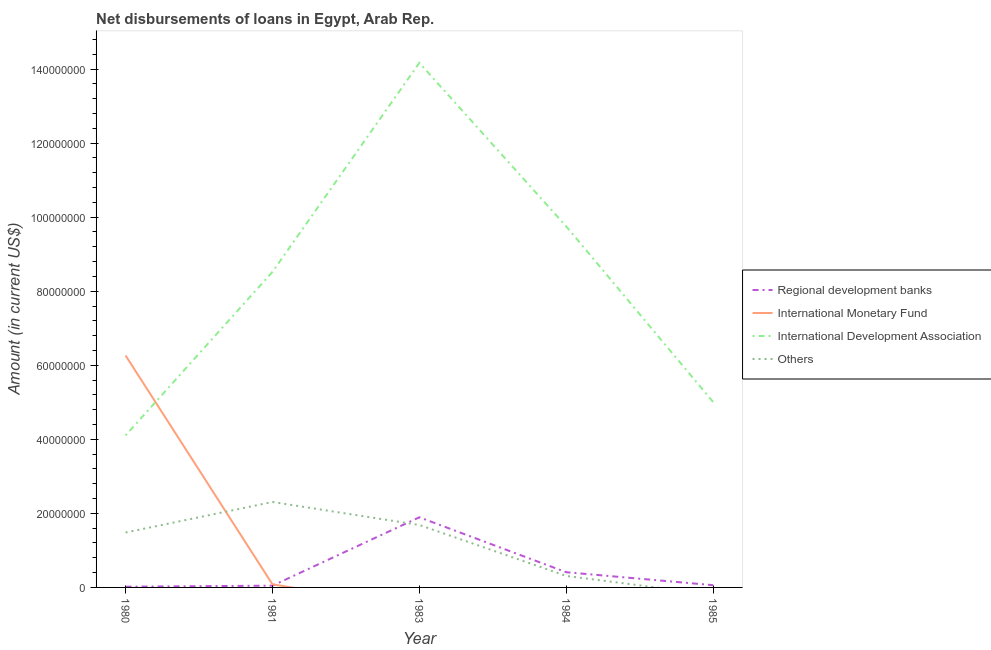How many different coloured lines are there?
Provide a succinct answer. 4. What is the amount of loan disimbursed by regional development banks in 1985?
Provide a short and direct response. 6.06e+05. Across all years, what is the maximum amount of loan disimbursed by international monetary fund?
Offer a very short reply. 6.26e+07. Across all years, what is the minimum amount of loan disimbursed by international monetary fund?
Give a very brief answer. 0. In which year was the amount of loan disimbursed by international monetary fund maximum?
Keep it short and to the point. 1980. What is the total amount of loan disimbursed by regional development banks in the graph?
Provide a short and direct response. 2.43e+07. What is the difference between the amount of loan disimbursed by other organisations in 1980 and that in 1981?
Offer a very short reply. -8.25e+06. What is the difference between the amount of loan disimbursed by regional development banks in 1984 and the amount of loan disimbursed by international monetary fund in 1983?
Offer a terse response. 4.10e+06. What is the average amount of loan disimbursed by international development association per year?
Provide a short and direct response. 8.31e+07. In the year 1981, what is the difference between the amount of loan disimbursed by other organisations and amount of loan disimbursed by international monetary fund?
Ensure brevity in your answer.  2.22e+07. In how many years, is the amount of loan disimbursed by international monetary fund greater than 28000000 US$?
Your answer should be compact. 1. What is the ratio of the amount of loan disimbursed by international development association in 1980 to that in 1984?
Provide a short and direct response. 0.42. What is the difference between the highest and the second highest amount of loan disimbursed by regional development banks?
Keep it short and to the point. 1.48e+07. What is the difference between the highest and the lowest amount of loan disimbursed by international development association?
Offer a terse response. 1.01e+08. In how many years, is the amount of loan disimbursed by international monetary fund greater than the average amount of loan disimbursed by international monetary fund taken over all years?
Keep it short and to the point. 1. Does the amount of loan disimbursed by other organisations monotonically increase over the years?
Make the answer very short. No. Is the amount of loan disimbursed by international monetary fund strictly less than the amount of loan disimbursed by regional development banks over the years?
Your response must be concise. No. What is the difference between two consecutive major ticks on the Y-axis?
Your answer should be very brief. 2.00e+07. Are the values on the major ticks of Y-axis written in scientific E-notation?
Your answer should be very brief. No. Does the graph contain any zero values?
Make the answer very short. Yes. Where does the legend appear in the graph?
Offer a terse response. Center right. How are the legend labels stacked?
Ensure brevity in your answer.  Vertical. What is the title of the graph?
Provide a succinct answer. Net disbursements of loans in Egypt, Arab Rep. Does "Tracking ability" appear as one of the legend labels in the graph?
Your answer should be very brief. No. What is the label or title of the Y-axis?
Make the answer very short. Amount (in current US$). What is the Amount (in current US$) in Regional development banks in 1980?
Your response must be concise. 1.92e+05. What is the Amount (in current US$) of International Monetary Fund in 1980?
Offer a terse response. 6.26e+07. What is the Amount (in current US$) in International Development Association in 1980?
Ensure brevity in your answer.  4.11e+07. What is the Amount (in current US$) in Others in 1980?
Provide a succinct answer. 1.48e+07. What is the Amount (in current US$) in Regional development banks in 1981?
Ensure brevity in your answer.  4.75e+05. What is the Amount (in current US$) in International Monetary Fund in 1981?
Give a very brief answer. 8.38e+05. What is the Amount (in current US$) in International Development Association in 1981?
Keep it short and to the point. 8.52e+07. What is the Amount (in current US$) of Others in 1981?
Your answer should be compact. 2.31e+07. What is the Amount (in current US$) of Regional development banks in 1983?
Your answer should be very brief. 1.89e+07. What is the Amount (in current US$) of International Monetary Fund in 1983?
Provide a succinct answer. 0. What is the Amount (in current US$) of International Development Association in 1983?
Offer a terse response. 1.42e+08. What is the Amount (in current US$) in Others in 1983?
Make the answer very short. 1.69e+07. What is the Amount (in current US$) of Regional development banks in 1984?
Offer a very short reply. 4.10e+06. What is the Amount (in current US$) of International Development Association in 1984?
Offer a terse response. 9.75e+07. What is the Amount (in current US$) of Others in 1984?
Make the answer very short. 3.10e+06. What is the Amount (in current US$) in Regional development banks in 1985?
Your response must be concise. 6.06e+05. What is the Amount (in current US$) in International Development Association in 1985?
Provide a succinct answer. 5.01e+07. What is the Amount (in current US$) in Others in 1985?
Provide a succinct answer. 0. Across all years, what is the maximum Amount (in current US$) in Regional development banks?
Offer a terse response. 1.89e+07. Across all years, what is the maximum Amount (in current US$) in International Monetary Fund?
Provide a succinct answer. 6.26e+07. Across all years, what is the maximum Amount (in current US$) of International Development Association?
Provide a short and direct response. 1.42e+08. Across all years, what is the maximum Amount (in current US$) in Others?
Provide a succinct answer. 2.31e+07. Across all years, what is the minimum Amount (in current US$) in Regional development banks?
Keep it short and to the point. 1.92e+05. Across all years, what is the minimum Amount (in current US$) in International Development Association?
Keep it short and to the point. 4.11e+07. Across all years, what is the minimum Amount (in current US$) in Others?
Your answer should be very brief. 0. What is the total Amount (in current US$) of Regional development banks in the graph?
Offer a very short reply. 2.43e+07. What is the total Amount (in current US$) in International Monetary Fund in the graph?
Ensure brevity in your answer.  6.35e+07. What is the total Amount (in current US$) of International Development Association in the graph?
Make the answer very short. 4.15e+08. What is the total Amount (in current US$) of Others in the graph?
Offer a terse response. 5.79e+07. What is the difference between the Amount (in current US$) in Regional development banks in 1980 and that in 1981?
Offer a very short reply. -2.83e+05. What is the difference between the Amount (in current US$) of International Monetary Fund in 1980 and that in 1981?
Make the answer very short. 6.18e+07. What is the difference between the Amount (in current US$) in International Development Association in 1980 and that in 1981?
Your answer should be compact. -4.42e+07. What is the difference between the Amount (in current US$) of Others in 1980 and that in 1981?
Keep it short and to the point. -8.25e+06. What is the difference between the Amount (in current US$) of Regional development banks in 1980 and that in 1983?
Your answer should be compact. -1.88e+07. What is the difference between the Amount (in current US$) of International Development Association in 1980 and that in 1983?
Your answer should be compact. -1.01e+08. What is the difference between the Amount (in current US$) in Others in 1980 and that in 1983?
Your answer should be compact. -2.04e+06. What is the difference between the Amount (in current US$) in Regional development banks in 1980 and that in 1984?
Provide a short and direct response. -3.91e+06. What is the difference between the Amount (in current US$) in International Development Association in 1980 and that in 1984?
Keep it short and to the point. -5.64e+07. What is the difference between the Amount (in current US$) of Others in 1980 and that in 1984?
Make the answer very short. 1.17e+07. What is the difference between the Amount (in current US$) in Regional development banks in 1980 and that in 1985?
Your answer should be very brief. -4.14e+05. What is the difference between the Amount (in current US$) of International Development Association in 1980 and that in 1985?
Ensure brevity in your answer.  -9.01e+06. What is the difference between the Amount (in current US$) of Regional development banks in 1981 and that in 1983?
Make the answer very short. -1.85e+07. What is the difference between the Amount (in current US$) in International Development Association in 1981 and that in 1983?
Make the answer very short. -5.65e+07. What is the difference between the Amount (in current US$) of Others in 1981 and that in 1983?
Offer a terse response. 6.21e+06. What is the difference between the Amount (in current US$) in Regional development banks in 1981 and that in 1984?
Your answer should be very brief. -3.63e+06. What is the difference between the Amount (in current US$) in International Development Association in 1981 and that in 1984?
Make the answer very short. -1.23e+07. What is the difference between the Amount (in current US$) in Others in 1981 and that in 1984?
Your answer should be very brief. 2.00e+07. What is the difference between the Amount (in current US$) in Regional development banks in 1981 and that in 1985?
Your answer should be compact. -1.31e+05. What is the difference between the Amount (in current US$) of International Development Association in 1981 and that in 1985?
Make the answer very short. 3.52e+07. What is the difference between the Amount (in current US$) in Regional development banks in 1983 and that in 1984?
Offer a very short reply. 1.48e+07. What is the difference between the Amount (in current US$) of International Development Association in 1983 and that in 1984?
Offer a terse response. 4.42e+07. What is the difference between the Amount (in current US$) of Others in 1983 and that in 1984?
Your answer should be compact. 1.38e+07. What is the difference between the Amount (in current US$) in Regional development banks in 1983 and that in 1985?
Your answer should be compact. 1.83e+07. What is the difference between the Amount (in current US$) in International Development Association in 1983 and that in 1985?
Offer a terse response. 9.16e+07. What is the difference between the Amount (in current US$) in Regional development banks in 1984 and that in 1985?
Your response must be concise. 3.50e+06. What is the difference between the Amount (in current US$) of International Development Association in 1984 and that in 1985?
Provide a short and direct response. 4.74e+07. What is the difference between the Amount (in current US$) in Regional development banks in 1980 and the Amount (in current US$) in International Monetary Fund in 1981?
Give a very brief answer. -6.46e+05. What is the difference between the Amount (in current US$) in Regional development banks in 1980 and the Amount (in current US$) in International Development Association in 1981?
Provide a succinct answer. -8.50e+07. What is the difference between the Amount (in current US$) in Regional development banks in 1980 and the Amount (in current US$) in Others in 1981?
Provide a succinct answer. -2.29e+07. What is the difference between the Amount (in current US$) of International Monetary Fund in 1980 and the Amount (in current US$) of International Development Association in 1981?
Your response must be concise. -2.26e+07. What is the difference between the Amount (in current US$) of International Monetary Fund in 1980 and the Amount (in current US$) of Others in 1981?
Your answer should be compact. 3.96e+07. What is the difference between the Amount (in current US$) in International Development Association in 1980 and the Amount (in current US$) in Others in 1981?
Give a very brief answer. 1.80e+07. What is the difference between the Amount (in current US$) of Regional development banks in 1980 and the Amount (in current US$) of International Development Association in 1983?
Keep it short and to the point. -1.41e+08. What is the difference between the Amount (in current US$) of Regional development banks in 1980 and the Amount (in current US$) of Others in 1983?
Keep it short and to the point. -1.67e+07. What is the difference between the Amount (in current US$) of International Monetary Fund in 1980 and the Amount (in current US$) of International Development Association in 1983?
Provide a short and direct response. -7.90e+07. What is the difference between the Amount (in current US$) in International Monetary Fund in 1980 and the Amount (in current US$) in Others in 1983?
Offer a very short reply. 4.58e+07. What is the difference between the Amount (in current US$) in International Development Association in 1980 and the Amount (in current US$) in Others in 1983?
Offer a very short reply. 2.42e+07. What is the difference between the Amount (in current US$) of Regional development banks in 1980 and the Amount (in current US$) of International Development Association in 1984?
Keep it short and to the point. -9.73e+07. What is the difference between the Amount (in current US$) of Regional development banks in 1980 and the Amount (in current US$) of Others in 1984?
Offer a very short reply. -2.91e+06. What is the difference between the Amount (in current US$) in International Monetary Fund in 1980 and the Amount (in current US$) in International Development Association in 1984?
Offer a very short reply. -3.48e+07. What is the difference between the Amount (in current US$) in International Monetary Fund in 1980 and the Amount (in current US$) in Others in 1984?
Give a very brief answer. 5.95e+07. What is the difference between the Amount (in current US$) in International Development Association in 1980 and the Amount (in current US$) in Others in 1984?
Provide a short and direct response. 3.80e+07. What is the difference between the Amount (in current US$) in Regional development banks in 1980 and the Amount (in current US$) in International Development Association in 1985?
Offer a terse response. -4.99e+07. What is the difference between the Amount (in current US$) in International Monetary Fund in 1980 and the Amount (in current US$) in International Development Association in 1985?
Offer a very short reply. 1.26e+07. What is the difference between the Amount (in current US$) of Regional development banks in 1981 and the Amount (in current US$) of International Development Association in 1983?
Offer a terse response. -1.41e+08. What is the difference between the Amount (in current US$) of Regional development banks in 1981 and the Amount (in current US$) of Others in 1983?
Give a very brief answer. -1.64e+07. What is the difference between the Amount (in current US$) of International Monetary Fund in 1981 and the Amount (in current US$) of International Development Association in 1983?
Give a very brief answer. -1.41e+08. What is the difference between the Amount (in current US$) in International Monetary Fund in 1981 and the Amount (in current US$) in Others in 1983?
Your answer should be compact. -1.60e+07. What is the difference between the Amount (in current US$) in International Development Association in 1981 and the Amount (in current US$) in Others in 1983?
Provide a succinct answer. 6.84e+07. What is the difference between the Amount (in current US$) of Regional development banks in 1981 and the Amount (in current US$) of International Development Association in 1984?
Offer a terse response. -9.70e+07. What is the difference between the Amount (in current US$) of Regional development banks in 1981 and the Amount (in current US$) of Others in 1984?
Offer a terse response. -2.63e+06. What is the difference between the Amount (in current US$) in International Monetary Fund in 1981 and the Amount (in current US$) in International Development Association in 1984?
Provide a succinct answer. -9.67e+07. What is the difference between the Amount (in current US$) of International Monetary Fund in 1981 and the Amount (in current US$) of Others in 1984?
Offer a terse response. -2.26e+06. What is the difference between the Amount (in current US$) in International Development Association in 1981 and the Amount (in current US$) in Others in 1984?
Ensure brevity in your answer.  8.21e+07. What is the difference between the Amount (in current US$) in Regional development banks in 1981 and the Amount (in current US$) in International Development Association in 1985?
Offer a terse response. -4.96e+07. What is the difference between the Amount (in current US$) of International Monetary Fund in 1981 and the Amount (in current US$) of International Development Association in 1985?
Keep it short and to the point. -4.92e+07. What is the difference between the Amount (in current US$) in Regional development banks in 1983 and the Amount (in current US$) in International Development Association in 1984?
Your answer should be very brief. -7.85e+07. What is the difference between the Amount (in current US$) of Regional development banks in 1983 and the Amount (in current US$) of Others in 1984?
Offer a terse response. 1.58e+07. What is the difference between the Amount (in current US$) of International Development Association in 1983 and the Amount (in current US$) of Others in 1984?
Make the answer very short. 1.39e+08. What is the difference between the Amount (in current US$) in Regional development banks in 1983 and the Amount (in current US$) in International Development Association in 1985?
Make the answer very short. -3.11e+07. What is the difference between the Amount (in current US$) of Regional development banks in 1984 and the Amount (in current US$) of International Development Association in 1985?
Your answer should be very brief. -4.60e+07. What is the average Amount (in current US$) of Regional development banks per year?
Offer a very short reply. 4.86e+06. What is the average Amount (in current US$) of International Monetary Fund per year?
Your answer should be compact. 1.27e+07. What is the average Amount (in current US$) of International Development Association per year?
Give a very brief answer. 8.31e+07. What is the average Amount (in current US$) of Others per year?
Ensure brevity in your answer.  1.16e+07. In the year 1980, what is the difference between the Amount (in current US$) in Regional development banks and Amount (in current US$) in International Monetary Fund?
Your answer should be very brief. -6.25e+07. In the year 1980, what is the difference between the Amount (in current US$) of Regional development banks and Amount (in current US$) of International Development Association?
Ensure brevity in your answer.  -4.09e+07. In the year 1980, what is the difference between the Amount (in current US$) of Regional development banks and Amount (in current US$) of Others?
Your answer should be very brief. -1.46e+07. In the year 1980, what is the difference between the Amount (in current US$) in International Monetary Fund and Amount (in current US$) in International Development Association?
Offer a terse response. 2.16e+07. In the year 1980, what is the difference between the Amount (in current US$) in International Monetary Fund and Amount (in current US$) in Others?
Your answer should be very brief. 4.78e+07. In the year 1980, what is the difference between the Amount (in current US$) in International Development Association and Amount (in current US$) in Others?
Keep it short and to the point. 2.62e+07. In the year 1981, what is the difference between the Amount (in current US$) of Regional development banks and Amount (in current US$) of International Monetary Fund?
Provide a succinct answer. -3.63e+05. In the year 1981, what is the difference between the Amount (in current US$) of Regional development banks and Amount (in current US$) of International Development Association?
Offer a very short reply. -8.47e+07. In the year 1981, what is the difference between the Amount (in current US$) in Regional development banks and Amount (in current US$) in Others?
Keep it short and to the point. -2.26e+07. In the year 1981, what is the difference between the Amount (in current US$) of International Monetary Fund and Amount (in current US$) of International Development Association?
Offer a very short reply. -8.44e+07. In the year 1981, what is the difference between the Amount (in current US$) of International Monetary Fund and Amount (in current US$) of Others?
Your answer should be very brief. -2.22e+07. In the year 1981, what is the difference between the Amount (in current US$) of International Development Association and Amount (in current US$) of Others?
Provide a succinct answer. 6.21e+07. In the year 1983, what is the difference between the Amount (in current US$) in Regional development banks and Amount (in current US$) in International Development Association?
Ensure brevity in your answer.  -1.23e+08. In the year 1983, what is the difference between the Amount (in current US$) in Regional development banks and Amount (in current US$) in Others?
Ensure brevity in your answer.  2.08e+06. In the year 1983, what is the difference between the Amount (in current US$) of International Development Association and Amount (in current US$) of Others?
Offer a very short reply. 1.25e+08. In the year 1984, what is the difference between the Amount (in current US$) in Regional development banks and Amount (in current US$) in International Development Association?
Give a very brief answer. -9.34e+07. In the year 1984, what is the difference between the Amount (in current US$) of International Development Association and Amount (in current US$) of Others?
Your response must be concise. 9.44e+07. In the year 1985, what is the difference between the Amount (in current US$) in Regional development banks and Amount (in current US$) in International Development Association?
Keep it short and to the point. -4.95e+07. What is the ratio of the Amount (in current US$) in Regional development banks in 1980 to that in 1981?
Ensure brevity in your answer.  0.4. What is the ratio of the Amount (in current US$) of International Monetary Fund in 1980 to that in 1981?
Your answer should be compact. 74.75. What is the ratio of the Amount (in current US$) in International Development Association in 1980 to that in 1981?
Ensure brevity in your answer.  0.48. What is the ratio of the Amount (in current US$) in Others in 1980 to that in 1981?
Ensure brevity in your answer.  0.64. What is the ratio of the Amount (in current US$) in Regional development banks in 1980 to that in 1983?
Ensure brevity in your answer.  0.01. What is the ratio of the Amount (in current US$) of International Development Association in 1980 to that in 1983?
Ensure brevity in your answer.  0.29. What is the ratio of the Amount (in current US$) in Others in 1980 to that in 1983?
Offer a terse response. 0.88. What is the ratio of the Amount (in current US$) in Regional development banks in 1980 to that in 1984?
Your answer should be very brief. 0.05. What is the ratio of the Amount (in current US$) of International Development Association in 1980 to that in 1984?
Offer a terse response. 0.42. What is the ratio of the Amount (in current US$) in Others in 1980 to that in 1984?
Your response must be concise. 4.78. What is the ratio of the Amount (in current US$) in Regional development banks in 1980 to that in 1985?
Keep it short and to the point. 0.32. What is the ratio of the Amount (in current US$) of International Development Association in 1980 to that in 1985?
Offer a terse response. 0.82. What is the ratio of the Amount (in current US$) of Regional development banks in 1981 to that in 1983?
Offer a terse response. 0.03. What is the ratio of the Amount (in current US$) of International Development Association in 1981 to that in 1983?
Your answer should be compact. 0.6. What is the ratio of the Amount (in current US$) of Others in 1981 to that in 1983?
Your answer should be compact. 1.37. What is the ratio of the Amount (in current US$) of Regional development banks in 1981 to that in 1984?
Your answer should be very brief. 0.12. What is the ratio of the Amount (in current US$) in International Development Association in 1981 to that in 1984?
Make the answer very short. 0.87. What is the ratio of the Amount (in current US$) of Others in 1981 to that in 1984?
Provide a short and direct response. 7.44. What is the ratio of the Amount (in current US$) of Regional development banks in 1981 to that in 1985?
Provide a succinct answer. 0.78. What is the ratio of the Amount (in current US$) in International Development Association in 1981 to that in 1985?
Ensure brevity in your answer.  1.7. What is the ratio of the Amount (in current US$) in Regional development banks in 1983 to that in 1984?
Keep it short and to the point. 4.62. What is the ratio of the Amount (in current US$) of International Development Association in 1983 to that in 1984?
Provide a short and direct response. 1.45. What is the ratio of the Amount (in current US$) of Others in 1983 to that in 1984?
Offer a very short reply. 5.43. What is the ratio of the Amount (in current US$) of Regional development banks in 1983 to that in 1985?
Provide a succinct answer. 31.26. What is the ratio of the Amount (in current US$) in International Development Association in 1983 to that in 1985?
Give a very brief answer. 2.83. What is the ratio of the Amount (in current US$) of Regional development banks in 1984 to that in 1985?
Offer a very short reply. 6.77. What is the ratio of the Amount (in current US$) in International Development Association in 1984 to that in 1985?
Provide a succinct answer. 1.95. What is the difference between the highest and the second highest Amount (in current US$) of Regional development banks?
Ensure brevity in your answer.  1.48e+07. What is the difference between the highest and the second highest Amount (in current US$) of International Development Association?
Provide a succinct answer. 4.42e+07. What is the difference between the highest and the second highest Amount (in current US$) in Others?
Make the answer very short. 6.21e+06. What is the difference between the highest and the lowest Amount (in current US$) in Regional development banks?
Offer a very short reply. 1.88e+07. What is the difference between the highest and the lowest Amount (in current US$) in International Monetary Fund?
Give a very brief answer. 6.26e+07. What is the difference between the highest and the lowest Amount (in current US$) in International Development Association?
Provide a succinct answer. 1.01e+08. What is the difference between the highest and the lowest Amount (in current US$) of Others?
Ensure brevity in your answer.  2.31e+07. 